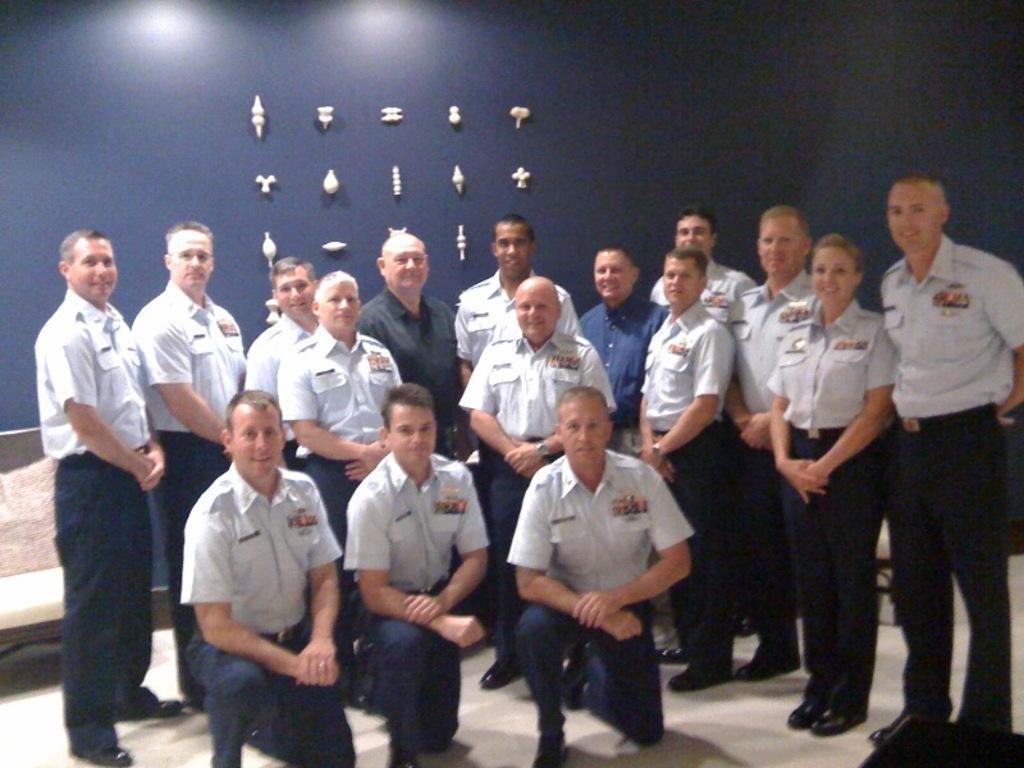What are the people in the image doing? The people in the image are standing on the floor. Can you describe the position of three persons in the image? There are three persons in a squat position in the image. What can be seen in the background of the image? There is a wall visible in the background of the image, and there are objects present as well. What type of popcorn can be seen floating in the lake in the image? There is no popcorn or lake present in the image; it features people standing and squatting on the floor with a wall and objects in the background. 